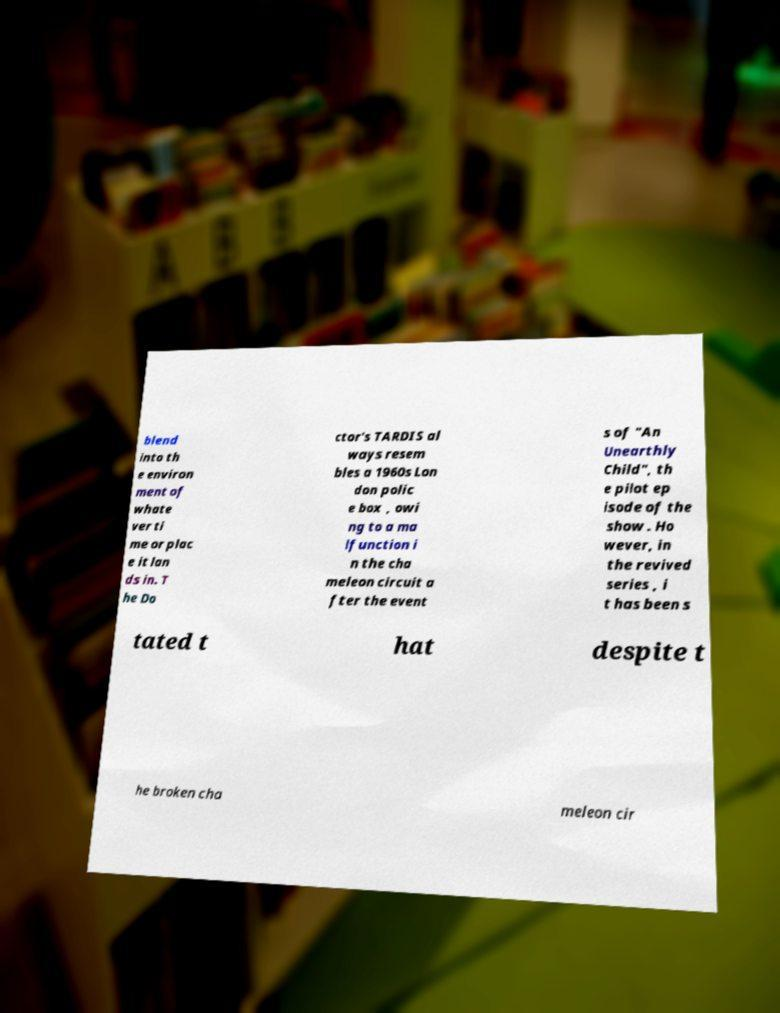Could you assist in decoding the text presented in this image and type it out clearly? blend into th e environ ment of whate ver ti me or plac e it lan ds in. T he Do ctor's TARDIS al ways resem bles a 1960s Lon don polic e box , owi ng to a ma lfunction i n the cha meleon circuit a fter the event s of "An Unearthly Child", th e pilot ep isode of the show . Ho wever, in the revived series , i t has been s tated t hat despite t he broken cha meleon cir 